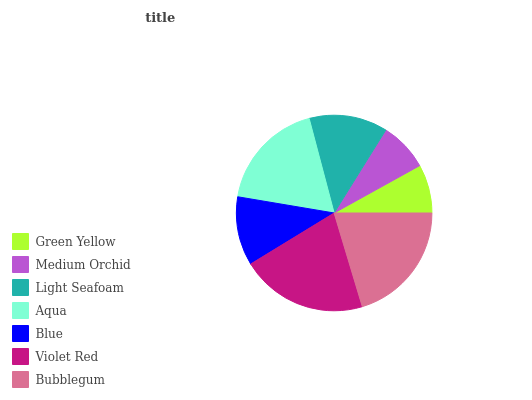Is Green Yellow the minimum?
Answer yes or no. Yes. Is Violet Red the maximum?
Answer yes or no. Yes. Is Medium Orchid the minimum?
Answer yes or no. No. Is Medium Orchid the maximum?
Answer yes or no. No. Is Medium Orchid greater than Green Yellow?
Answer yes or no. Yes. Is Green Yellow less than Medium Orchid?
Answer yes or no. Yes. Is Green Yellow greater than Medium Orchid?
Answer yes or no. No. Is Medium Orchid less than Green Yellow?
Answer yes or no. No. Is Light Seafoam the high median?
Answer yes or no. Yes. Is Light Seafoam the low median?
Answer yes or no. Yes. Is Blue the high median?
Answer yes or no. No. Is Bubblegum the low median?
Answer yes or no. No. 